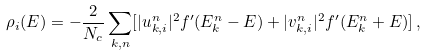Convert formula to latex. <formula><loc_0><loc_0><loc_500><loc_500>\rho _ { i } ( E ) = - \frac { 2 } { N _ { c } } \sum _ { k , n } [ | u ^ { n } _ { k , i } | ^ { 2 } f ^ { \prime } ( E ^ { n } _ { k } - E ) + | v ^ { n } _ { k , i } | ^ { 2 } f ^ { \prime } ( E ^ { n } _ { k } + E ) ] \, ,</formula> 